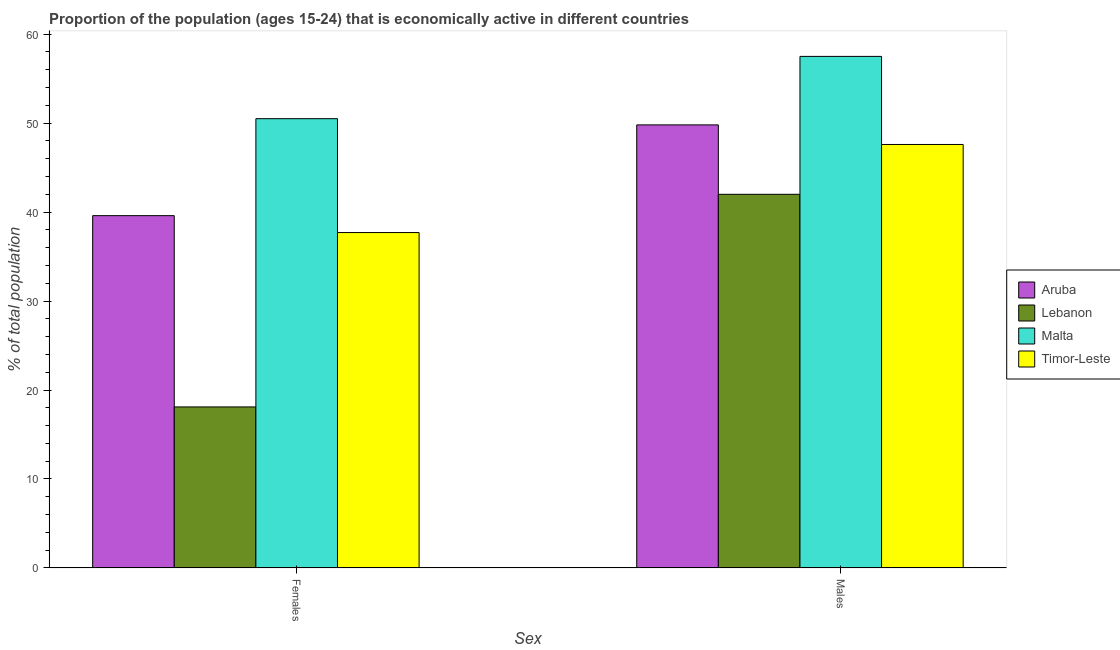How many groups of bars are there?
Provide a succinct answer. 2. Are the number of bars per tick equal to the number of legend labels?
Offer a very short reply. Yes. Are the number of bars on each tick of the X-axis equal?
Offer a very short reply. Yes. How many bars are there on the 2nd tick from the left?
Ensure brevity in your answer.  4. How many bars are there on the 2nd tick from the right?
Provide a short and direct response. 4. What is the label of the 2nd group of bars from the left?
Your answer should be very brief. Males. What is the percentage of economically active male population in Aruba?
Your answer should be very brief. 49.8. Across all countries, what is the maximum percentage of economically active female population?
Make the answer very short. 50.5. Across all countries, what is the minimum percentage of economically active female population?
Offer a very short reply. 18.1. In which country was the percentage of economically active female population maximum?
Provide a succinct answer. Malta. In which country was the percentage of economically active male population minimum?
Ensure brevity in your answer.  Lebanon. What is the total percentage of economically active female population in the graph?
Keep it short and to the point. 145.9. What is the difference between the percentage of economically active female population in Timor-Leste and that in Aruba?
Keep it short and to the point. -1.9. What is the difference between the percentage of economically active male population in Timor-Leste and the percentage of economically active female population in Malta?
Offer a terse response. -2.9. What is the average percentage of economically active male population per country?
Make the answer very short. 49.22. What is the difference between the percentage of economically active male population and percentage of economically active female population in Timor-Leste?
Provide a short and direct response. 9.9. What is the ratio of the percentage of economically active female population in Timor-Leste to that in Malta?
Provide a short and direct response. 0.75. Is the percentage of economically active male population in Aruba less than that in Malta?
Your answer should be compact. Yes. In how many countries, is the percentage of economically active male population greater than the average percentage of economically active male population taken over all countries?
Give a very brief answer. 2. What does the 1st bar from the left in Females represents?
Provide a short and direct response. Aruba. What does the 4th bar from the right in Females represents?
Offer a terse response. Aruba. Are all the bars in the graph horizontal?
Provide a short and direct response. No. Does the graph contain grids?
Provide a succinct answer. No. Where does the legend appear in the graph?
Provide a short and direct response. Center right. What is the title of the graph?
Offer a terse response. Proportion of the population (ages 15-24) that is economically active in different countries. What is the label or title of the X-axis?
Keep it short and to the point. Sex. What is the label or title of the Y-axis?
Ensure brevity in your answer.  % of total population. What is the % of total population of Aruba in Females?
Offer a terse response. 39.6. What is the % of total population in Lebanon in Females?
Provide a short and direct response. 18.1. What is the % of total population in Malta in Females?
Your answer should be compact. 50.5. What is the % of total population of Timor-Leste in Females?
Provide a succinct answer. 37.7. What is the % of total population in Aruba in Males?
Give a very brief answer. 49.8. What is the % of total population of Malta in Males?
Make the answer very short. 57.5. What is the % of total population of Timor-Leste in Males?
Your answer should be very brief. 47.6. Across all Sex, what is the maximum % of total population of Aruba?
Your answer should be very brief. 49.8. Across all Sex, what is the maximum % of total population of Malta?
Give a very brief answer. 57.5. Across all Sex, what is the maximum % of total population of Timor-Leste?
Ensure brevity in your answer.  47.6. Across all Sex, what is the minimum % of total population in Aruba?
Keep it short and to the point. 39.6. Across all Sex, what is the minimum % of total population in Lebanon?
Offer a very short reply. 18.1. Across all Sex, what is the minimum % of total population in Malta?
Offer a very short reply. 50.5. Across all Sex, what is the minimum % of total population of Timor-Leste?
Make the answer very short. 37.7. What is the total % of total population in Aruba in the graph?
Offer a terse response. 89.4. What is the total % of total population in Lebanon in the graph?
Give a very brief answer. 60.1. What is the total % of total population of Malta in the graph?
Give a very brief answer. 108. What is the total % of total population of Timor-Leste in the graph?
Make the answer very short. 85.3. What is the difference between the % of total population of Lebanon in Females and that in Males?
Ensure brevity in your answer.  -23.9. What is the difference between the % of total population of Timor-Leste in Females and that in Males?
Your response must be concise. -9.9. What is the difference between the % of total population in Aruba in Females and the % of total population in Malta in Males?
Your answer should be very brief. -17.9. What is the difference between the % of total population in Aruba in Females and the % of total population in Timor-Leste in Males?
Your answer should be very brief. -8. What is the difference between the % of total population in Lebanon in Females and the % of total population in Malta in Males?
Provide a succinct answer. -39.4. What is the difference between the % of total population in Lebanon in Females and the % of total population in Timor-Leste in Males?
Ensure brevity in your answer.  -29.5. What is the average % of total population in Aruba per Sex?
Give a very brief answer. 44.7. What is the average % of total population in Lebanon per Sex?
Your answer should be compact. 30.05. What is the average % of total population in Timor-Leste per Sex?
Keep it short and to the point. 42.65. What is the difference between the % of total population of Lebanon and % of total population of Malta in Females?
Provide a succinct answer. -32.4. What is the difference between the % of total population in Lebanon and % of total population in Timor-Leste in Females?
Offer a terse response. -19.6. What is the difference between the % of total population of Malta and % of total population of Timor-Leste in Females?
Make the answer very short. 12.8. What is the difference between the % of total population in Lebanon and % of total population in Malta in Males?
Ensure brevity in your answer.  -15.5. What is the difference between the % of total population in Lebanon and % of total population in Timor-Leste in Males?
Your response must be concise. -5.6. What is the ratio of the % of total population of Aruba in Females to that in Males?
Give a very brief answer. 0.8. What is the ratio of the % of total population in Lebanon in Females to that in Males?
Keep it short and to the point. 0.43. What is the ratio of the % of total population in Malta in Females to that in Males?
Offer a terse response. 0.88. What is the ratio of the % of total population in Timor-Leste in Females to that in Males?
Make the answer very short. 0.79. What is the difference between the highest and the second highest % of total population in Aruba?
Your answer should be very brief. 10.2. What is the difference between the highest and the second highest % of total population of Lebanon?
Make the answer very short. 23.9. What is the difference between the highest and the second highest % of total population of Malta?
Give a very brief answer. 7. What is the difference between the highest and the second highest % of total population of Timor-Leste?
Offer a very short reply. 9.9. What is the difference between the highest and the lowest % of total population in Aruba?
Your answer should be compact. 10.2. What is the difference between the highest and the lowest % of total population in Lebanon?
Make the answer very short. 23.9. What is the difference between the highest and the lowest % of total population in Malta?
Offer a terse response. 7. 